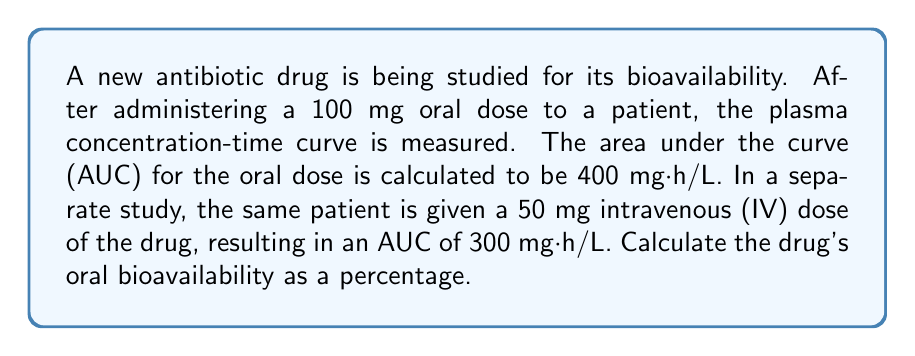Teach me how to tackle this problem. To calculate the oral bioavailability, we need to compare the AUC of the oral dose to that of the IV dose, while accounting for the different doses administered. The formula for bioavailability (F) is:

$$ F = \frac{AUC_{oral} \cdot Dose_{IV}}{AUC_{IV} \cdot Dose_{oral}} \cdot 100\% $$

Let's plug in the values:

$AUC_{oral} = 400$ mg·h/L
$Dose_{oral} = 100$ mg
$AUC_{IV} = 300$ mg·h/L
$Dose_{IV} = 50$ mg

$$ F = \frac{400 \cdot 50}{300 \cdot 100} \cdot 100\% $$

Simplifying:

$$ F = \frac{20000}{30000} \cdot 100\% $$

$$ F = 0.6667 \cdot 100\% $$

$$ F = 66.67\% $$

Therefore, the oral bioavailability of the antibiotic drug is approximately 66.67%.
Answer: 66.67% 